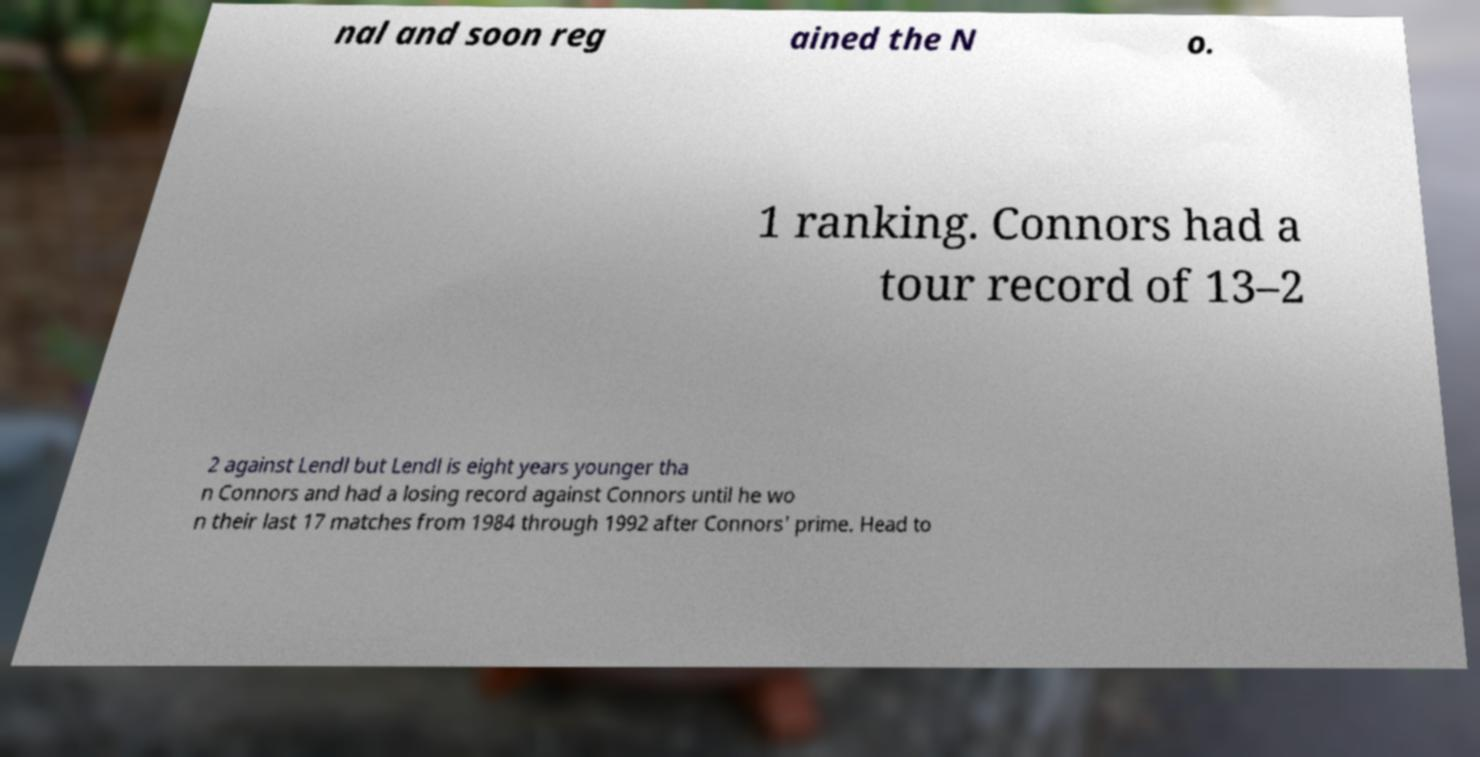I need the written content from this picture converted into text. Can you do that? nal and soon reg ained the N o. 1 ranking. Connors had a tour record of 13–2 2 against Lendl but Lendl is eight years younger tha n Connors and had a losing record against Connors until he wo n their last 17 matches from 1984 through 1992 after Connors' prime. Head to 